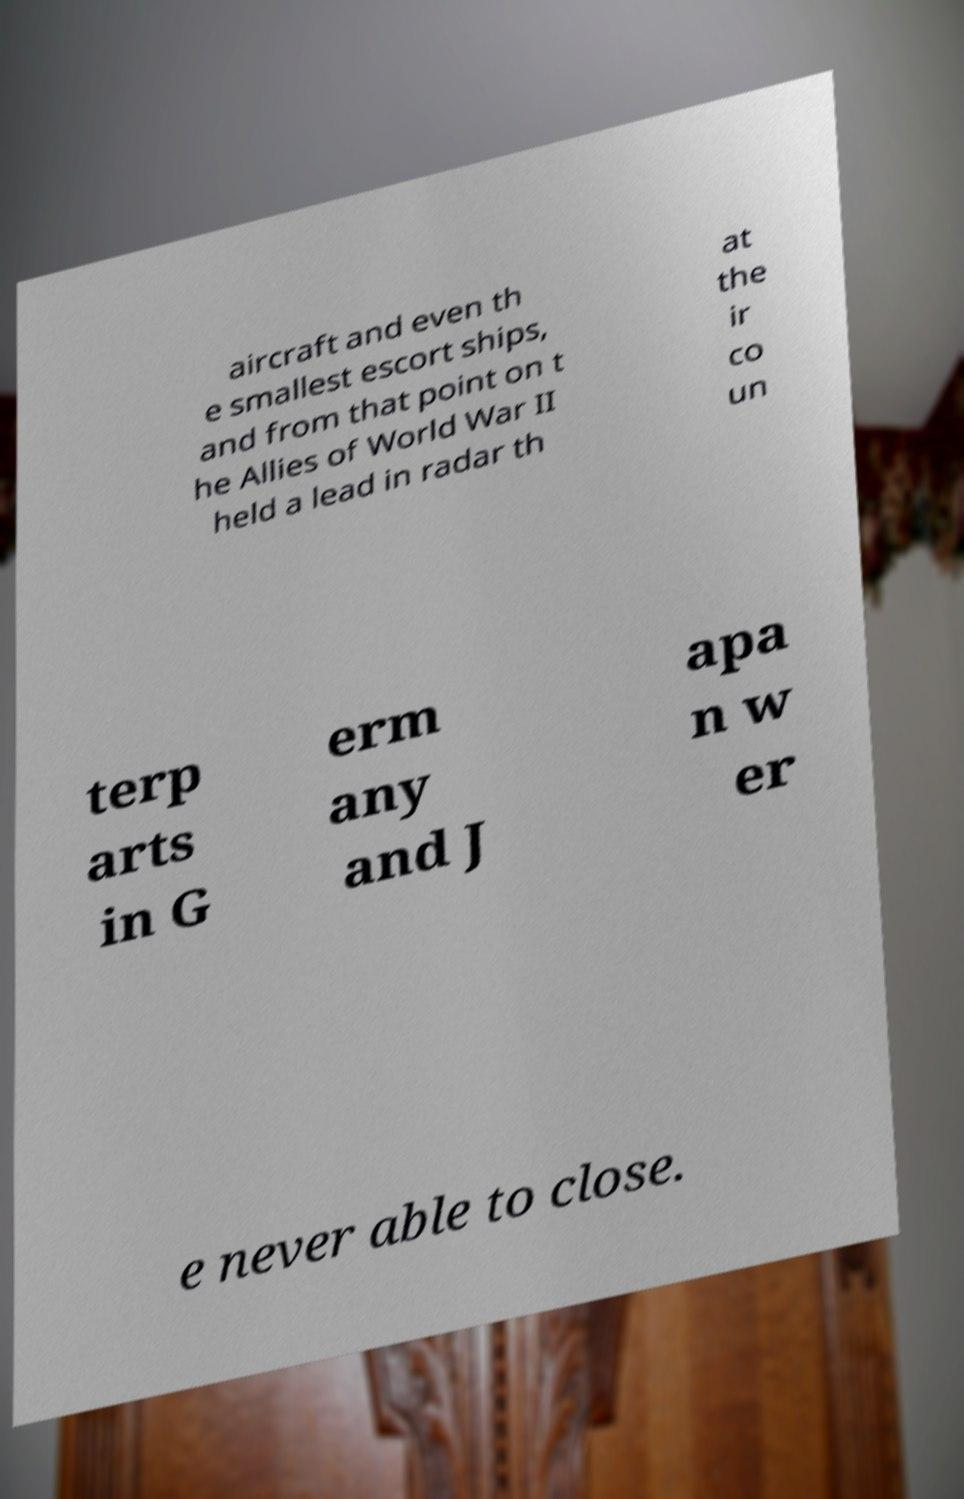What messages or text are displayed in this image? I need them in a readable, typed format. aircraft and even th e smallest escort ships, and from that point on t he Allies of World War II held a lead in radar th at the ir co un terp arts in G erm any and J apa n w er e never able to close. 